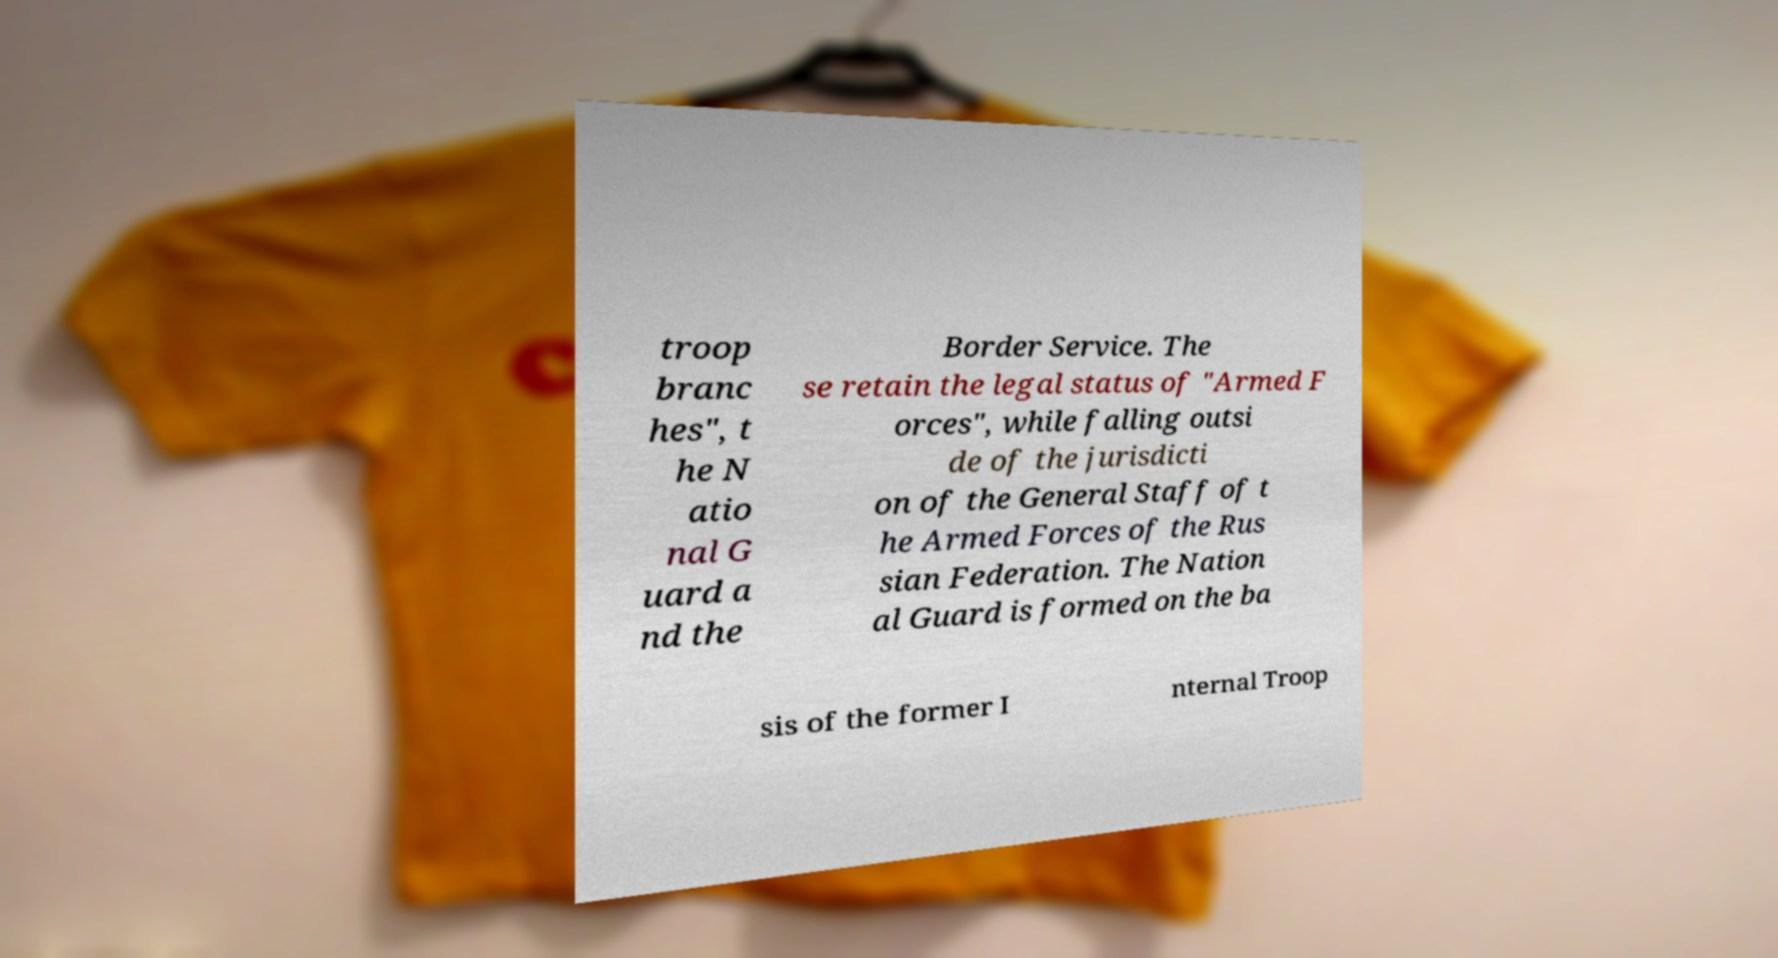Please read and relay the text visible in this image. What does it say? troop branc hes", t he N atio nal G uard a nd the Border Service. The se retain the legal status of "Armed F orces", while falling outsi de of the jurisdicti on of the General Staff of t he Armed Forces of the Rus sian Federation. The Nation al Guard is formed on the ba sis of the former I nternal Troop 